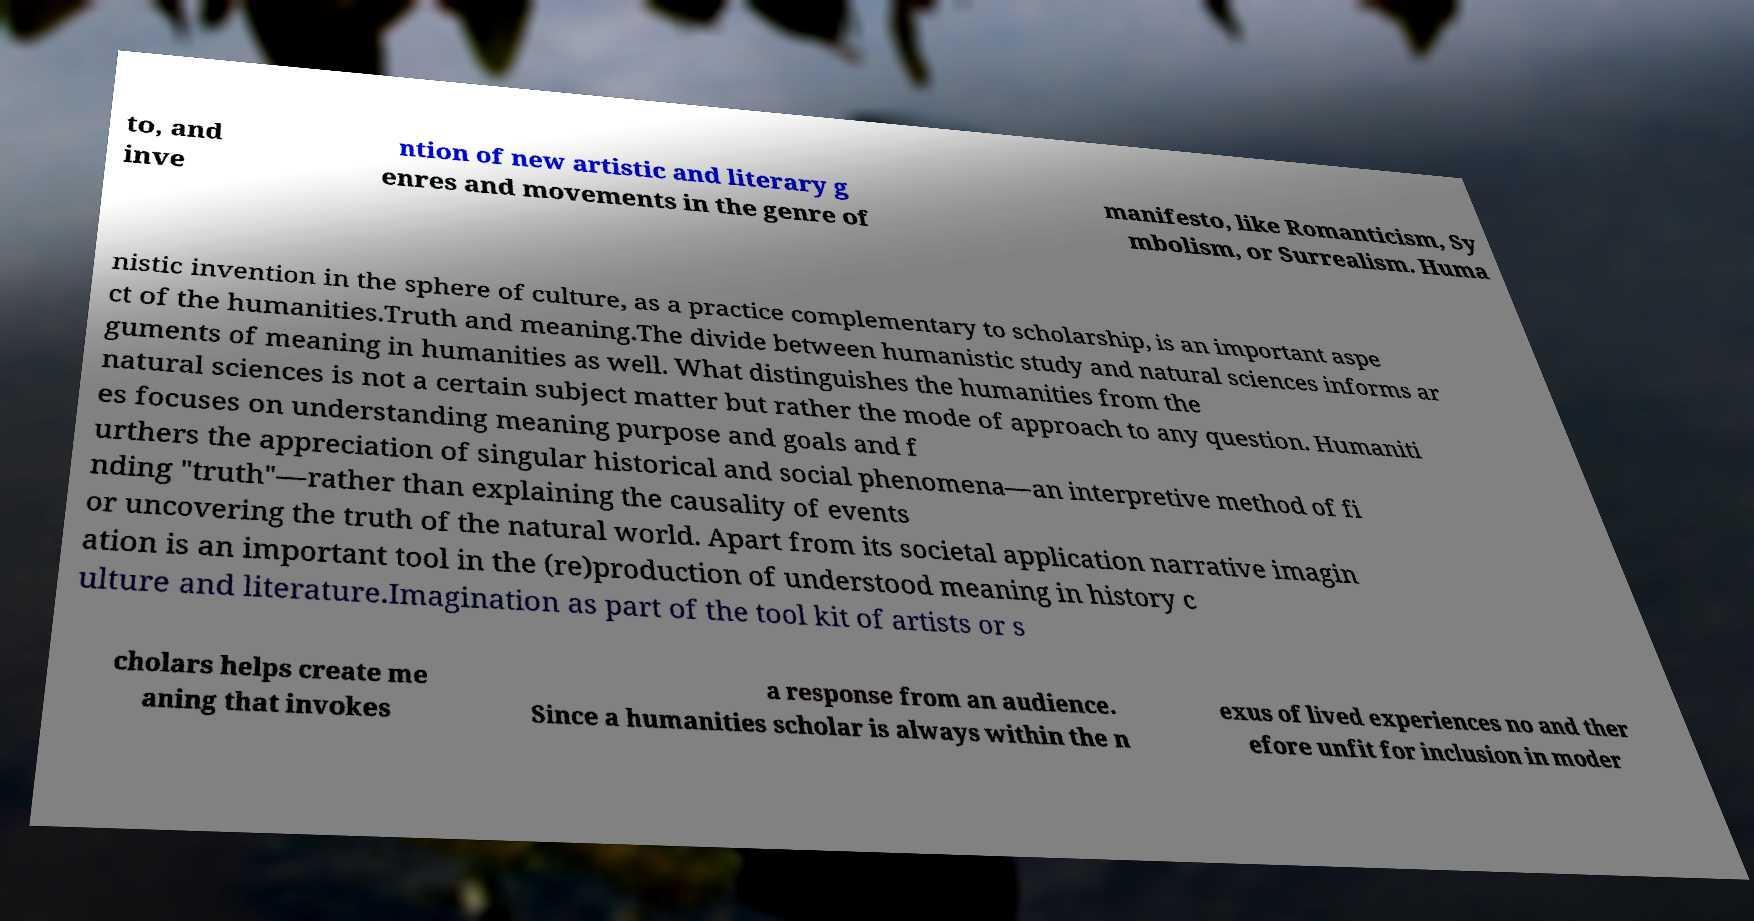I need the written content from this picture converted into text. Can you do that? to, and inve ntion of new artistic and literary g enres and movements in the genre of manifesto, like Romanticism, Sy mbolism, or Surrealism. Huma nistic invention in the sphere of culture, as a practice complementary to scholarship, is an important aspe ct of the humanities.Truth and meaning.The divide between humanistic study and natural sciences informs ar guments of meaning in humanities as well. What distinguishes the humanities from the natural sciences is not a certain subject matter but rather the mode of approach to any question. Humaniti es focuses on understanding meaning purpose and goals and f urthers the appreciation of singular historical and social phenomena—an interpretive method of fi nding "truth"—rather than explaining the causality of events or uncovering the truth of the natural world. Apart from its societal application narrative imagin ation is an important tool in the (re)production of understood meaning in history c ulture and literature.Imagination as part of the tool kit of artists or s cholars helps create me aning that invokes a response from an audience. Since a humanities scholar is always within the n exus of lived experiences no and ther efore unfit for inclusion in moder 